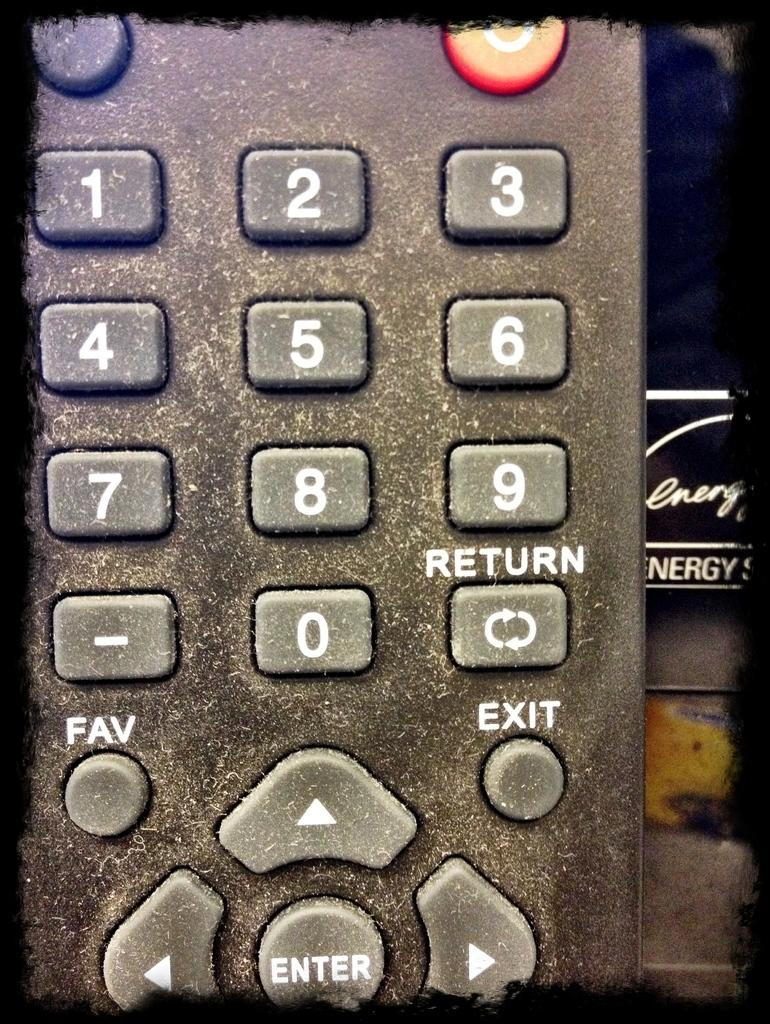<image>
Describe the image concisely. a remote with the number 9 on the front of it 